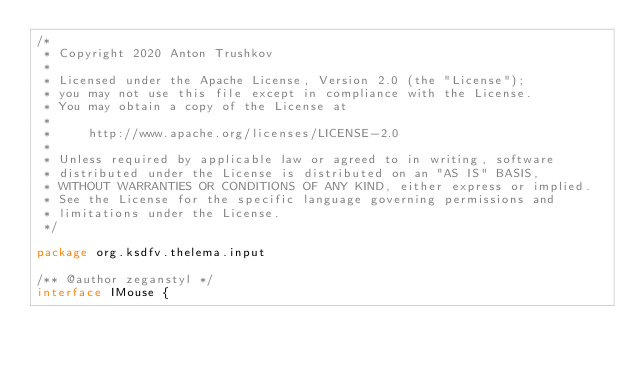Convert code to text. <code><loc_0><loc_0><loc_500><loc_500><_Kotlin_>/*
 * Copyright 2020 Anton Trushkov
 *
 * Licensed under the Apache License, Version 2.0 (the "License");
 * you may not use this file except in compliance with the License.
 * You may obtain a copy of the License at
 *
 *     http://www.apache.org/licenses/LICENSE-2.0
 *
 * Unless required by applicable law or agreed to in writing, software
 * distributed under the License is distributed on an "AS IS" BASIS,
 * WITHOUT WARRANTIES OR CONDITIONS OF ANY KIND, either express or implied.
 * See the License for the specific language governing permissions and
 * limitations under the License.
 */

package org.ksdfv.thelema.input

/** @author zeganstyl */
interface IMouse {</code> 